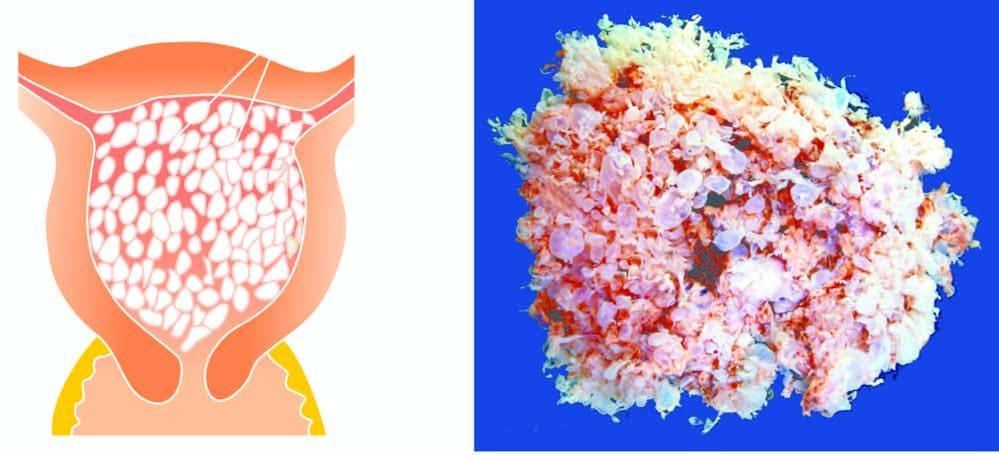what does the specimen show?
Answer the question using a single word or phrase. Numerous 